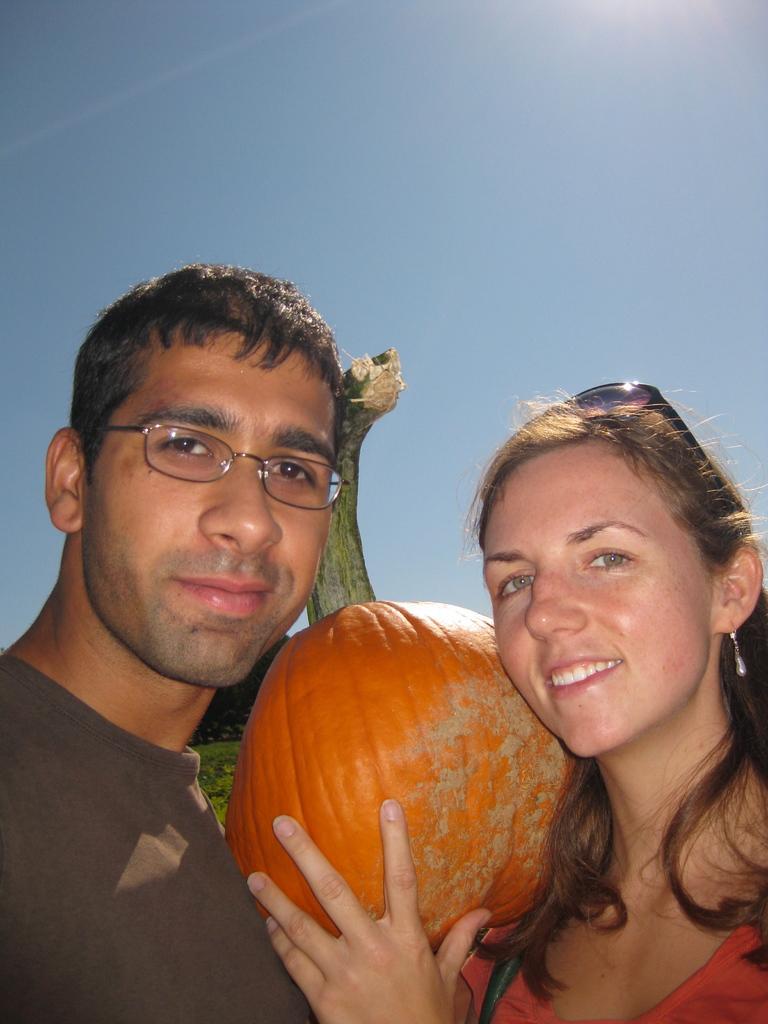In one or two sentences, can you explain what this image depicts? This is the man and woman standing and smiling. This woman is holding a big pumpkin. I can see the sky. 